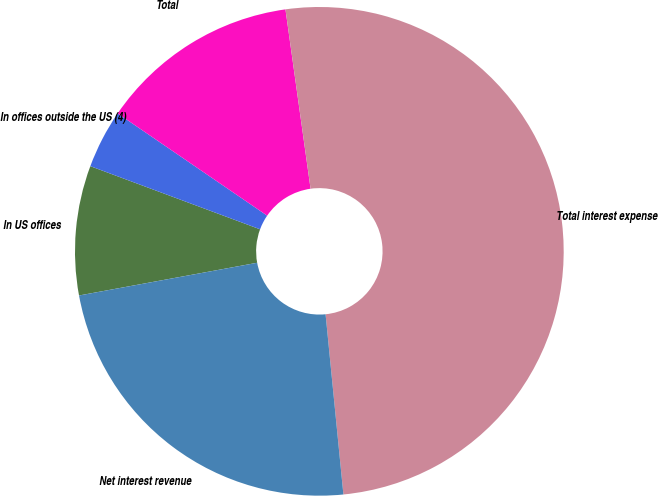Convert chart. <chart><loc_0><loc_0><loc_500><loc_500><pie_chart><fcel>In US offices<fcel>In offices outside the US (4)<fcel>Total<fcel>Total interest expense<fcel>Net interest revenue<nl><fcel>8.56%<fcel>3.88%<fcel>13.24%<fcel>50.65%<fcel>23.68%<nl></chart> 